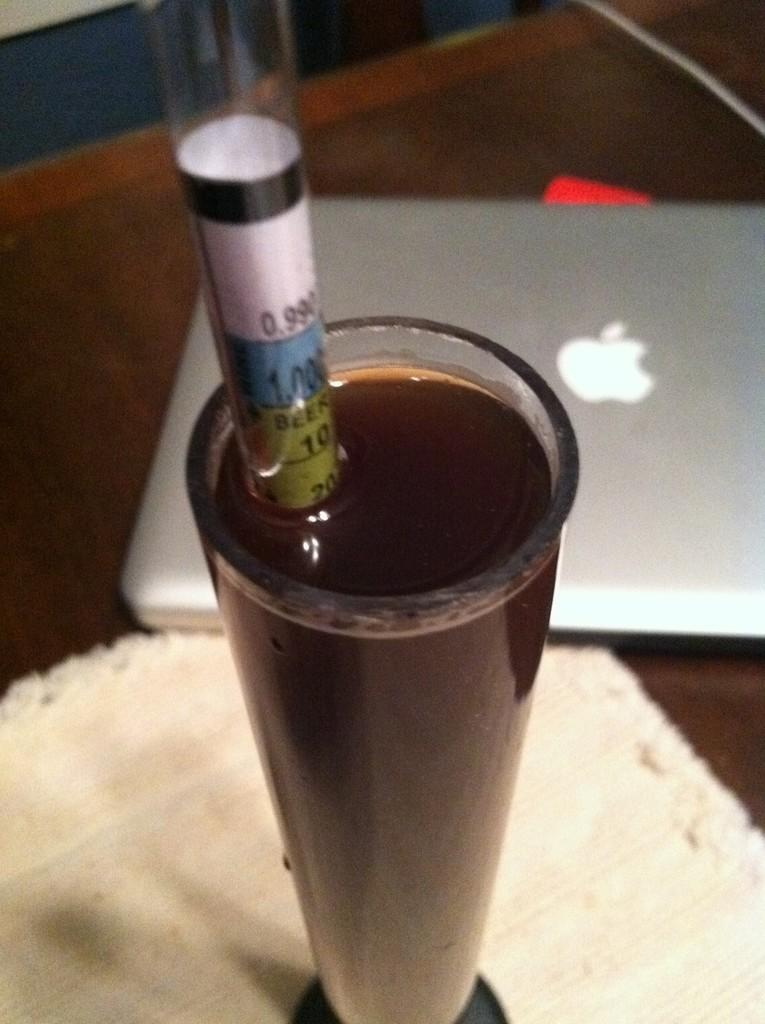What is in the glass that is visible in the image? There is a drink in the glass in the image. What is connected to the glass? There is a tube associated with the glass. What electronic device is present in the image? There is a laptop in the image. What type of material is present in the image? There is a cloth in the image. On what surface are the objects placed? The objects are on a platform in the image. What type of secretary is sitting next to the laptop in the image? There is no secretary present in the image; it only features a glass with a drink, a tube, a laptop, a cloth, and a platform. What type of ship can be seen sailing in the background of the image? There is no ship visible in the image; it only features objects on a platform. 